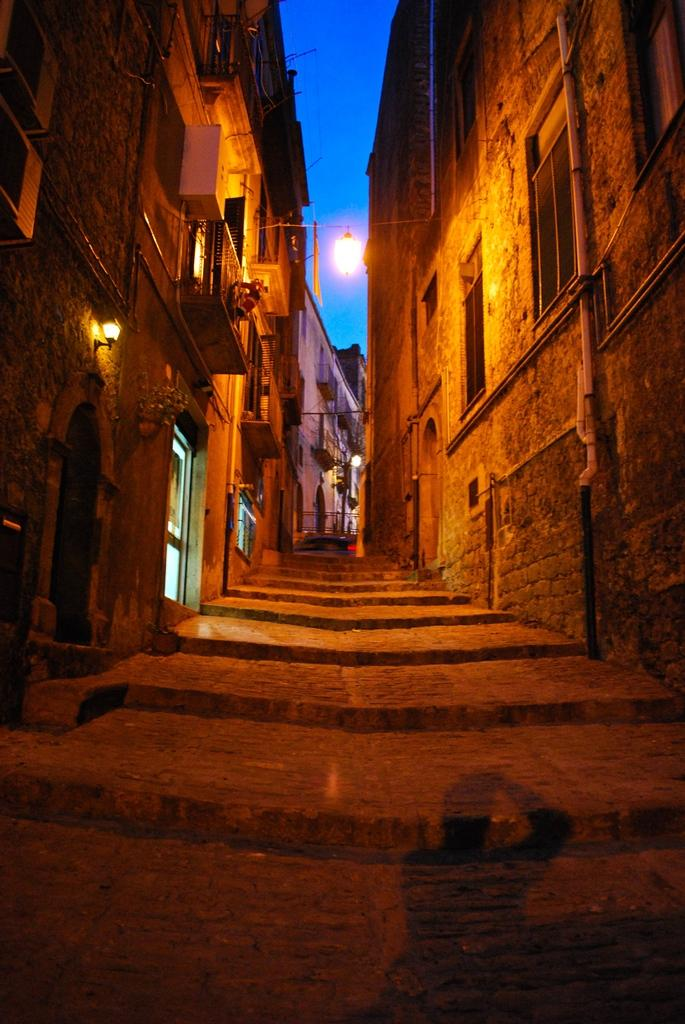What structures are present on both sides of the image? There are buildings on both sides of the image. What features can be observed on the buildings? The buildings have windows and lights. What architectural element is present between the buildings? There are steps between the buildings. What can be seen in the background of the image? The sky is visible in the background of the image. Can you tell me how many donkeys are grazing on the steps between the buildings? There are no donkeys present in the image; the steps are between the buildings, which have windows and lights. What type of office can be seen in the image? There is no office depicted in the image; it features buildings with windows and lights, steps between them, and a visible sky in the background. 